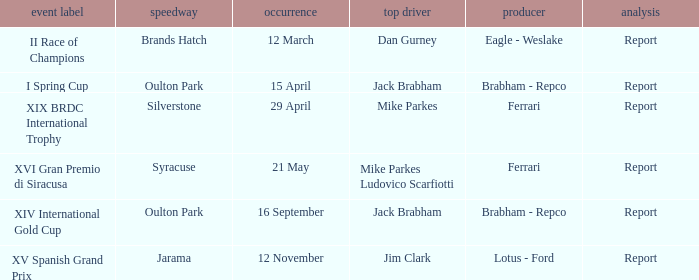What company constrcuted the vehicle with a circuit of oulton park on 15 april? Brabham - Repco. 